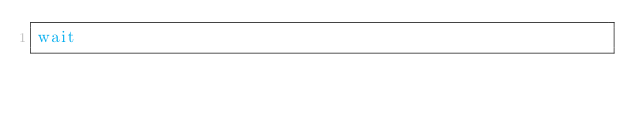<code> <loc_0><loc_0><loc_500><loc_500><_Bash_>wait
</code> 